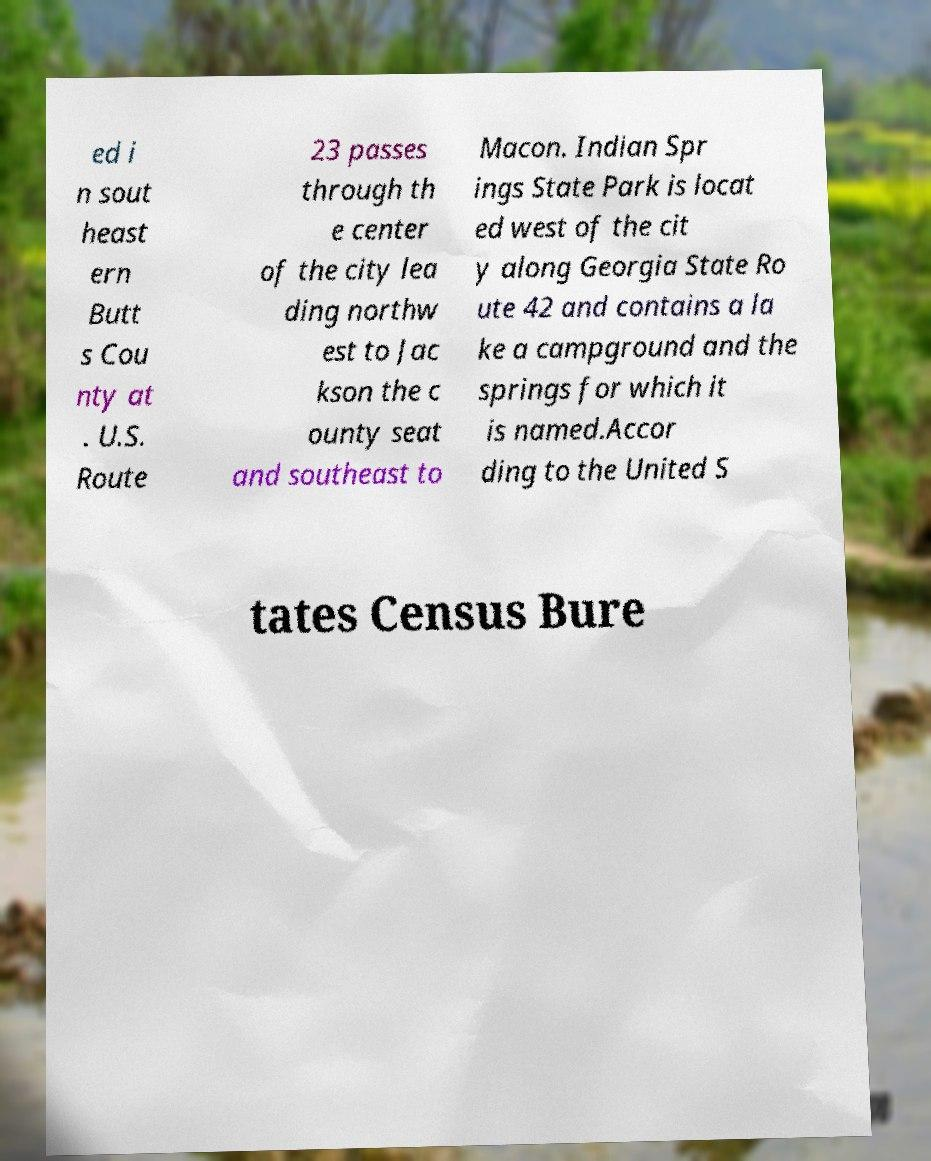What messages or text are displayed in this image? I need them in a readable, typed format. ed i n sout heast ern Butt s Cou nty at . U.S. Route 23 passes through th e center of the city lea ding northw est to Jac kson the c ounty seat and southeast to Macon. Indian Spr ings State Park is locat ed west of the cit y along Georgia State Ro ute 42 and contains a la ke a campground and the springs for which it is named.Accor ding to the United S tates Census Bure 